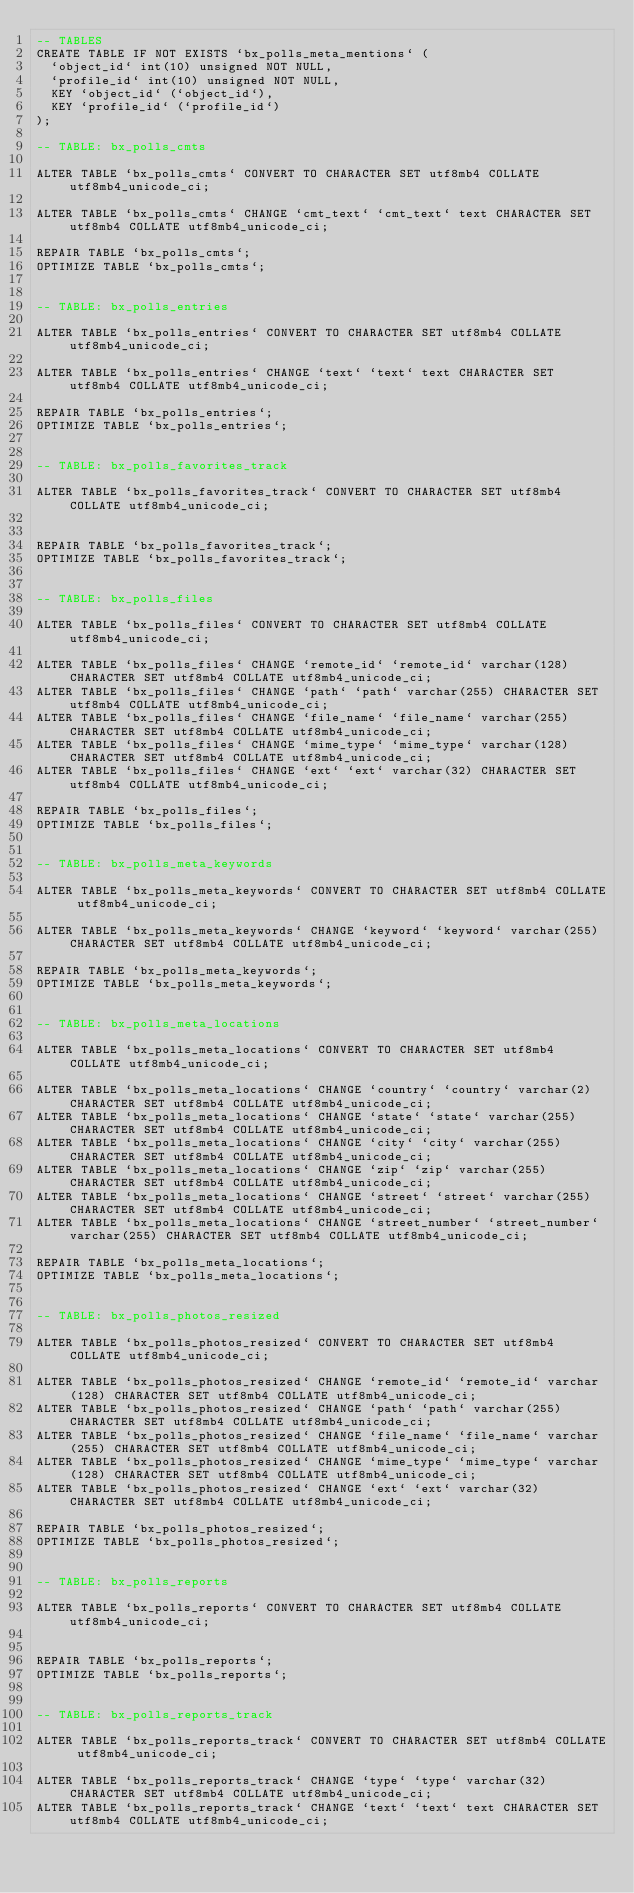Convert code to text. <code><loc_0><loc_0><loc_500><loc_500><_SQL_>-- TABLES
CREATE TABLE IF NOT EXISTS `bx_polls_meta_mentions` (
  `object_id` int(10) unsigned NOT NULL,
  `profile_id` int(10) unsigned NOT NULL,
  KEY `object_id` (`object_id`),
  KEY `profile_id` (`profile_id`)
);

-- TABLE: bx_polls_cmts

ALTER TABLE `bx_polls_cmts` CONVERT TO CHARACTER SET utf8mb4 COLLATE utf8mb4_unicode_ci;

ALTER TABLE `bx_polls_cmts` CHANGE `cmt_text` `cmt_text` text CHARACTER SET utf8mb4 COLLATE utf8mb4_unicode_ci;

REPAIR TABLE `bx_polls_cmts`;
OPTIMIZE TABLE `bx_polls_cmts`;


-- TABLE: bx_polls_entries

ALTER TABLE `bx_polls_entries` CONVERT TO CHARACTER SET utf8mb4 COLLATE utf8mb4_unicode_ci;

ALTER TABLE `bx_polls_entries` CHANGE `text` `text` text CHARACTER SET utf8mb4 COLLATE utf8mb4_unicode_ci;

REPAIR TABLE `bx_polls_entries`;
OPTIMIZE TABLE `bx_polls_entries`;


-- TABLE: bx_polls_favorites_track

ALTER TABLE `bx_polls_favorites_track` CONVERT TO CHARACTER SET utf8mb4 COLLATE utf8mb4_unicode_ci;


REPAIR TABLE `bx_polls_favorites_track`;
OPTIMIZE TABLE `bx_polls_favorites_track`;


-- TABLE: bx_polls_files

ALTER TABLE `bx_polls_files` CONVERT TO CHARACTER SET utf8mb4 COLLATE utf8mb4_unicode_ci;

ALTER TABLE `bx_polls_files` CHANGE `remote_id` `remote_id` varchar(128) CHARACTER SET utf8mb4 COLLATE utf8mb4_unicode_ci;
ALTER TABLE `bx_polls_files` CHANGE `path` `path` varchar(255) CHARACTER SET utf8mb4 COLLATE utf8mb4_unicode_ci;
ALTER TABLE `bx_polls_files` CHANGE `file_name` `file_name` varchar(255) CHARACTER SET utf8mb4 COLLATE utf8mb4_unicode_ci;
ALTER TABLE `bx_polls_files` CHANGE `mime_type` `mime_type` varchar(128) CHARACTER SET utf8mb4 COLLATE utf8mb4_unicode_ci;
ALTER TABLE `bx_polls_files` CHANGE `ext` `ext` varchar(32) CHARACTER SET utf8mb4 COLLATE utf8mb4_unicode_ci;

REPAIR TABLE `bx_polls_files`;
OPTIMIZE TABLE `bx_polls_files`;


-- TABLE: bx_polls_meta_keywords

ALTER TABLE `bx_polls_meta_keywords` CONVERT TO CHARACTER SET utf8mb4 COLLATE utf8mb4_unicode_ci;

ALTER TABLE `bx_polls_meta_keywords` CHANGE `keyword` `keyword` varchar(255) CHARACTER SET utf8mb4 COLLATE utf8mb4_unicode_ci;

REPAIR TABLE `bx_polls_meta_keywords`;
OPTIMIZE TABLE `bx_polls_meta_keywords`;


-- TABLE: bx_polls_meta_locations

ALTER TABLE `bx_polls_meta_locations` CONVERT TO CHARACTER SET utf8mb4 COLLATE utf8mb4_unicode_ci;

ALTER TABLE `bx_polls_meta_locations` CHANGE `country` `country` varchar(2) CHARACTER SET utf8mb4 COLLATE utf8mb4_unicode_ci;
ALTER TABLE `bx_polls_meta_locations` CHANGE `state` `state` varchar(255) CHARACTER SET utf8mb4 COLLATE utf8mb4_unicode_ci;
ALTER TABLE `bx_polls_meta_locations` CHANGE `city` `city` varchar(255) CHARACTER SET utf8mb4 COLLATE utf8mb4_unicode_ci;
ALTER TABLE `bx_polls_meta_locations` CHANGE `zip` `zip` varchar(255) CHARACTER SET utf8mb4 COLLATE utf8mb4_unicode_ci;
ALTER TABLE `bx_polls_meta_locations` CHANGE `street` `street` varchar(255) CHARACTER SET utf8mb4 COLLATE utf8mb4_unicode_ci;
ALTER TABLE `bx_polls_meta_locations` CHANGE `street_number` `street_number` varchar(255) CHARACTER SET utf8mb4 COLLATE utf8mb4_unicode_ci;

REPAIR TABLE `bx_polls_meta_locations`;
OPTIMIZE TABLE `bx_polls_meta_locations`;


-- TABLE: bx_polls_photos_resized

ALTER TABLE `bx_polls_photos_resized` CONVERT TO CHARACTER SET utf8mb4 COLLATE utf8mb4_unicode_ci;

ALTER TABLE `bx_polls_photos_resized` CHANGE `remote_id` `remote_id` varchar(128) CHARACTER SET utf8mb4 COLLATE utf8mb4_unicode_ci;
ALTER TABLE `bx_polls_photos_resized` CHANGE `path` `path` varchar(255) CHARACTER SET utf8mb4 COLLATE utf8mb4_unicode_ci;
ALTER TABLE `bx_polls_photos_resized` CHANGE `file_name` `file_name` varchar(255) CHARACTER SET utf8mb4 COLLATE utf8mb4_unicode_ci;
ALTER TABLE `bx_polls_photos_resized` CHANGE `mime_type` `mime_type` varchar(128) CHARACTER SET utf8mb4 COLLATE utf8mb4_unicode_ci;
ALTER TABLE `bx_polls_photos_resized` CHANGE `ext` `ext` varchar(32) CHARACTER SET utf8mb4 COLLATE utf8mb4_unicode_ci;

REPAIR TABLE `bx_polls_photos_resized`;
OPTIMIZE TABLE `bx_polls_photos_resized`;


-- TABLE: bx_polls_reports

ALTER TABLE `bx_polls_reports` CONVERT TO CHARACTER SET utf8mb4 COLLATE utf8mb4_unicode_ci;


REPAIR TABLE `bx_polls_reports`;
OPTIMIZE TABLE `bx_polls_reports`;


-- TABLE: bx_polls_reports_track

ALTER TABLE `bx_polls_reports_track` CONVERT TO CHARACTER SET utf8mb4 COLLATE utf8mb4_unicode_ci;

ALTER TABLE `bx_polls_reports_track` CHANGE `type` `type` varchar(32) CHARACTER SET utf8mb4 COLLATE utf8mb4_unicode_ci;
ALTER TABLE `bx_polls_reports_track` CHANGE `text` `text` text CHARACTER SET utf8mb4 COLLATE utf8mb4_unicode_ci;
</code> 